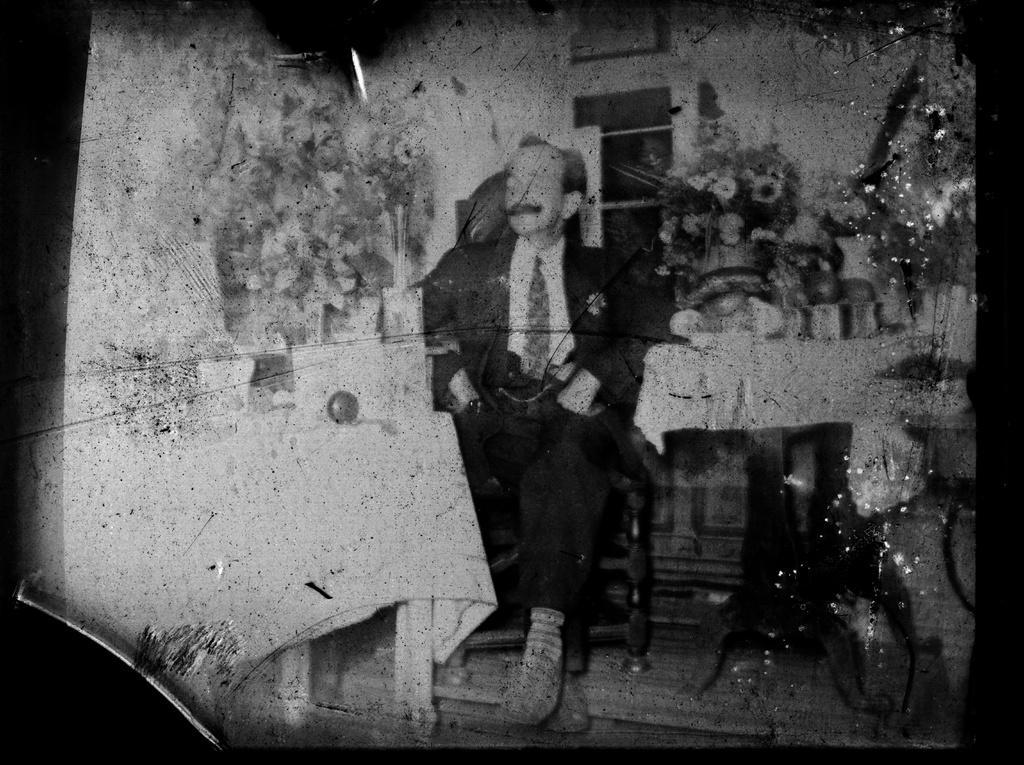Describe this image in one or two sentences. In this image I can see the photography of the person wearing the blazer, shirt and the tie. To the side of the person I can see some objects on the table. And this is a black and white photo. 